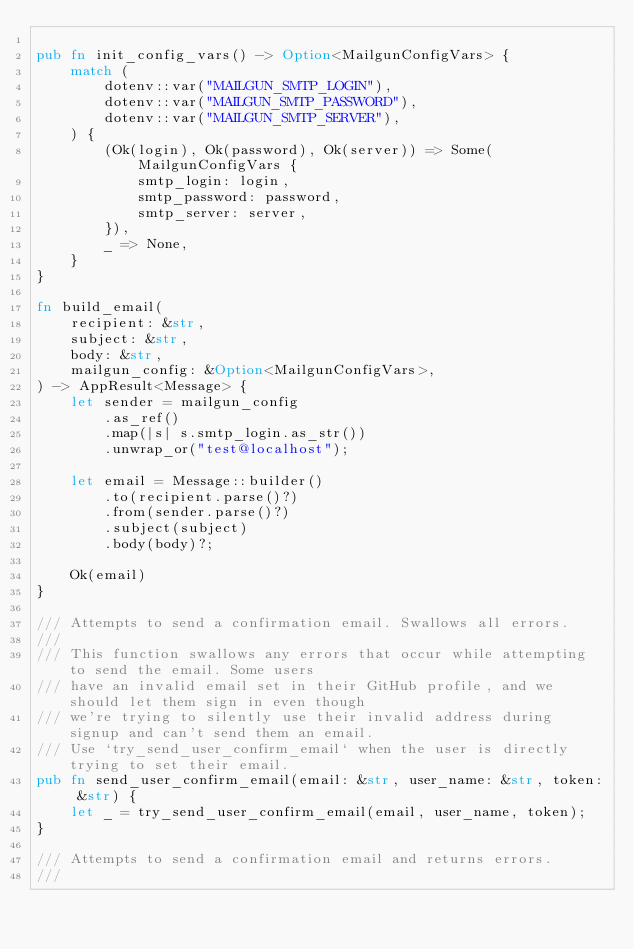<code> <loc_0><loc_0><loc_500><loc_500><_Rust_>
pub fn init_config_vars() -> Option<MailgunConfigVars> {
    match (
        dotenv::var("MAILGUN_SMTP_LOGIN"),
        dotenv::var("MAILGUN_SMTP_PASSWORD"),
        dotenv::var("MAILGUN_SMTP_SERVER"),
    ) {
        (Ok(login), Ok(password), Ok(server)) => Some(MailgunConfigVars {
            smtp_login: login,
            smtp_password: password,
            smtp_server: server,
        }),
        _ => None,
    }
}

fn build_email(
    recipient: &str,
    subject: &str,
    body: &str,
    mailgun_config: &Option<MailgunConfigVars>,
) -> AppResult<Message> {
    let sender = mailgun_config
        .as_ref()
        .map(|s| s.smtp_login.as_str())
        .unwrap_or("test@localhost");

    let email = Message::builder()
        .to(recipient.parse()?)
        .from(sender.parse()?)
        .subject(subject)
        .body(body)?;

    Ok(email)
}

/// Attempts to send a confirmation email. Swallows all errors.
///
/// This function swallows any errors that occur while attempting to send the email. Some users
/// have an invalid email set in their GitHub profile, and we should let them sign in even though
/// we're trying to silently use their invalid address during signup and can't send them an email.
/// Use `try_send_user_confirm_email` when the user is directly trying to set their email.
pub fn send_user_confirm_email(email: &str, user_name: &str, token: &str) {
    let _ = try_send_user_confirm_email(email, user_name, token);
}

/// Attempts to send a confirmation email and returns errors.
///</code> 